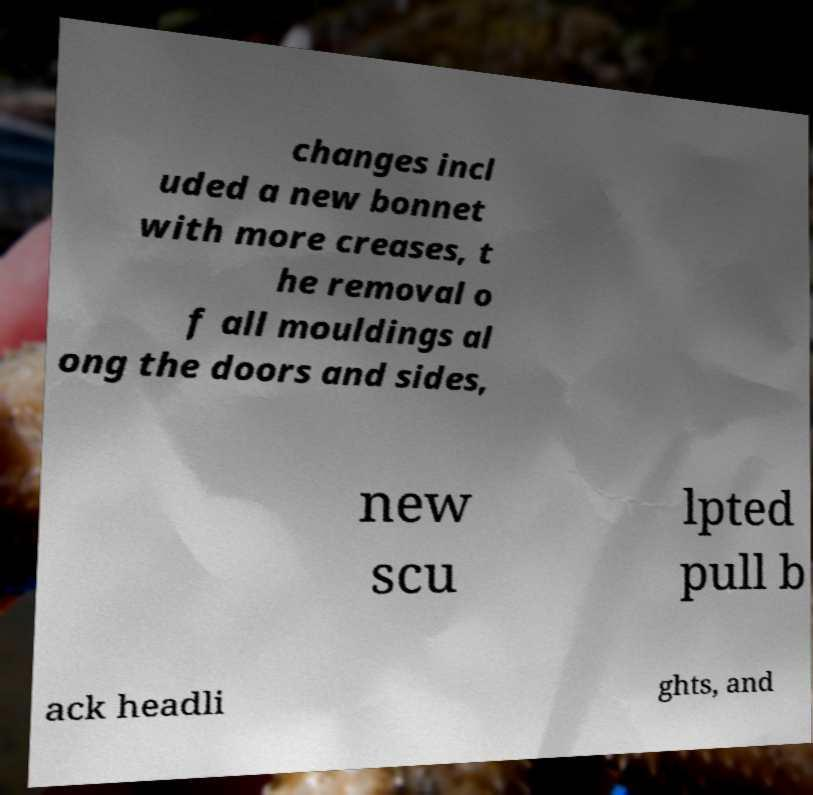Please identify and transcribe the text found in this image. changes incl uded a new bonnet with more creases, t he removal o f all mouldings al ong the doors and sides, new scu lpted pull b ack headli ghts, and 